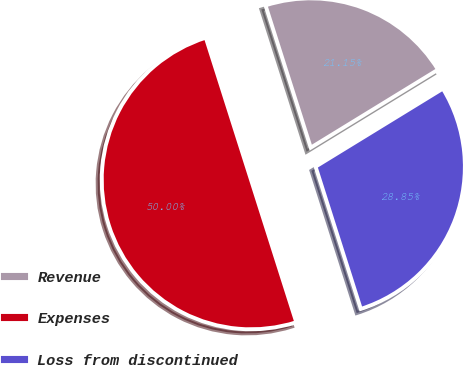Convert chart to OTSL. <chart><loc_0><loc_0><loc_500><loc_500><pie_chart><fcel>Revenue<fcel>Expenses<fcel>Loss from discontinued<nl><fcel>21.15%<fcel>50.0%<fcel>28.85%<nl></chart> 